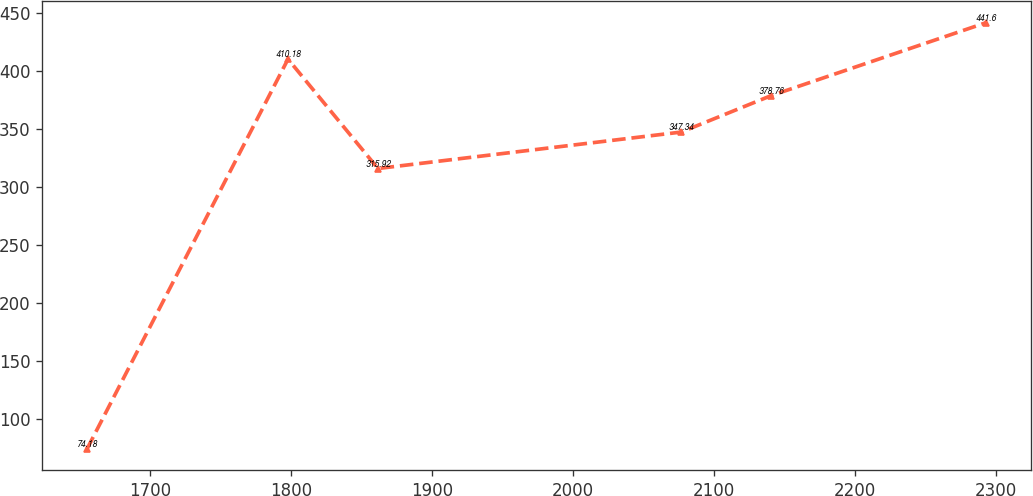Convert chart. <chart><loc_0><loc_0><loc_500><loc_500><line_chart><ecel><fcel>Unnamed: 1<nl><fcel>1655.45<fcel>74.18<nl><fcel>1797.96<fcel>410.18<nl><fcel>1861.7<fcel>315.92<nl><fcel>2076.77<fcel>347.34<nl><fcel>2140.51<fcel>378.76<nl><fcel>2292.83<fcel>441.6<nl></chart> 